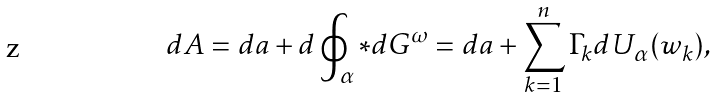<formula> <loc_0><loc_0><loc_500><loc_500>d A = d a + d \oint _ { \alpha } * d G ^ { \omega } = d a + \sum _ { k = 1 } ^ { n } \Gamma _ { k } d U _ { \alpha } ( w _ { k } ) ,</formula> 